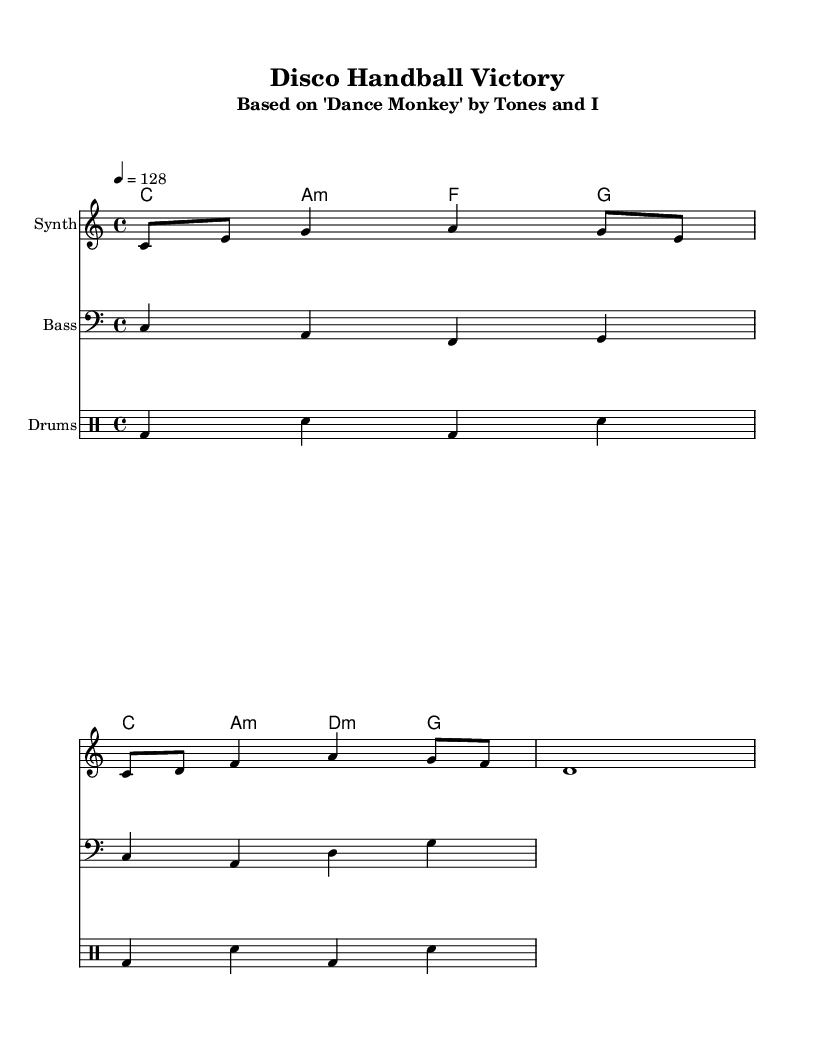What is the key signature of this music? The key signature is C major, which has no sharps or flats.
Answer: C major What is the time signature of the piece? The time signature is indicated at the beginning of the sheet music, showing there are four beats per measure.
Answer: 4/4 What is the tempo of this music? The tempo marking is given as a quarter note equals 128 beats per minute, indicating a fast-paced rhythm suitable for disco.
Answer: 128 How many measures are there in the melody? By counting the sections in the melody line, we see there are three measures represented.
Answer: 3 What type of instruments are included in the score? The score includes a Synth, Bass, and Drums, which are common in disco music for an upbeat feel.
Answer: Synth, Bass, Drums Which contemporary pop song is this disco piece based on? The title in the header states that it is based on "Dance Monkey" by Tones and I, identifying the original song.
Answer: Dance Monkey What are the primary chords used in this arrangement? Looking at the chord names, the primary chords used are C, A minor, F, and G, which are typical in disco arrangements.
Answer: C, A minor, F, G 